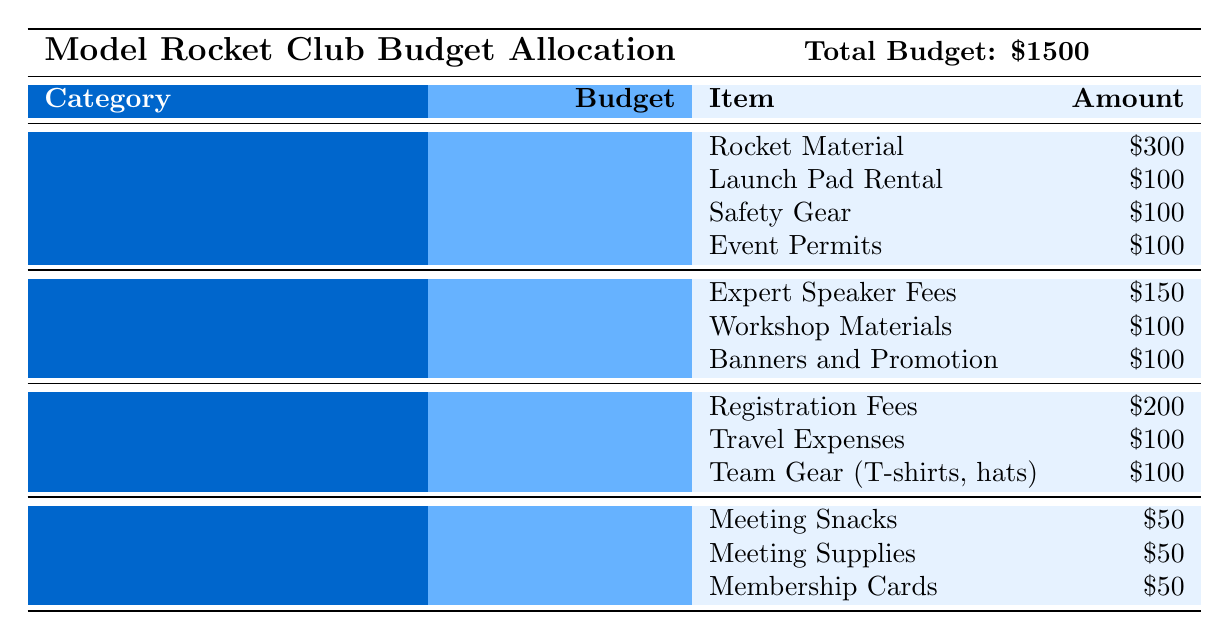What is the total budget for the Model Rocket Club? The total budget for the Model Rocket Club is explicitly mentioned in the table at the top right corner. It states "Total Budget: $1500."
Answer: 1500 How much is allocated for Launch Events? The budget allocated for Launch Events is listed next to the category title. According to the table, it states "$600."
Answer: 600 What item costs the most in the Workshops category? In the Workshops category, the items listed are Expert Speaker Fees, Workshop Materials, and Banners and Promotion. The highest cost is the Expert Speaker Fees at $150.
Answer: Expert Speaker Fees What is the total amount allocated for Competition Participation? The budget for Competition Participation is stated in the table as "$400." This does not involve any calculation.
Answer: 400 How much more budget is allocated for Launch Events than for Club Maintenance? Launch Events budget is $600, and Club Maintenance budget is $150. To find the difference, subtract $150 from $600, which is $450.
Answer: 450 Is the budget for Workshops greater than that of Club Maintenance? Workshops budget is $350 while Club Maintenance is $150. Since $350 is greater than $150, the answer is yes.
Answer: Yes What is the total budget for items in Launch Events? The Launch Events items are Rocket Material ($300), Launch Pad Rental ($100), Safety Gear ($100), and Event Permits ($100). Adding these: 300 + 100 + 100 + 100 = $600, confirming the total budget for Launch Events.
Answer: 600 What percentage of the total budget is spent on Club Maintenance? The budget for Club Maintenance is $150. To calculate the percentage of the total budget ($1500), use the formula: (150/1500) * 100, which equals 10%.
Answer: 10% How much budget is left after spending on all categories? The total spending across all categories is $1500. Since it was the total budget, the remaining amount is $1500 - $1500 = $0.
Answer: 0 If the budget for Workshops were to increase by $50, what would the new total budget be? The original budget for Workshops is $350. If it increases by $50, the new budget would be $350 + $50 = $400. Since the total budget is fixed at $1500, it remains the same, but Workshops would now be $400.
Answer: 1500 (total budget remains unchanged) 